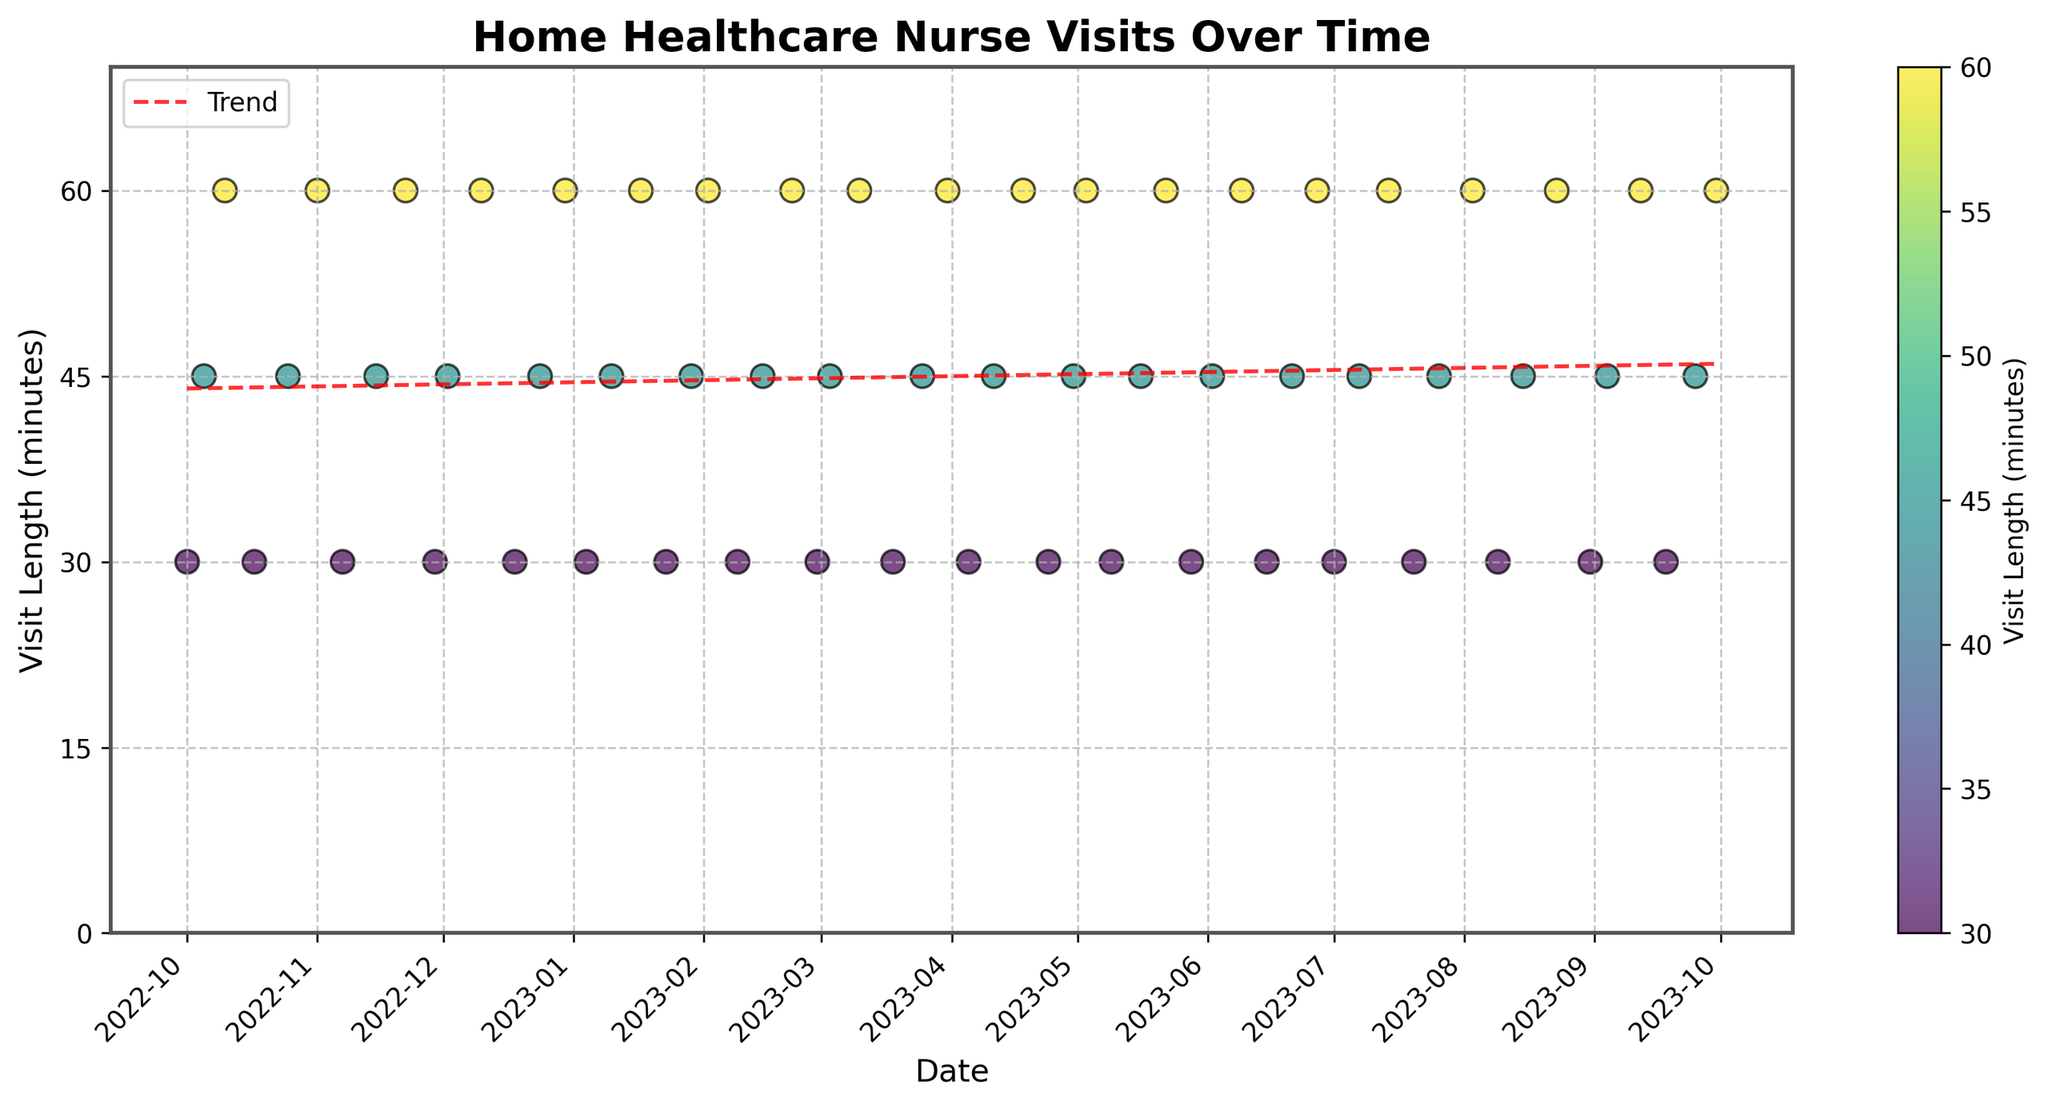What's the title of the figure? The title of the figure is displayed at the top of the chart in bold font. It typically describes the data shown in the plot.
Answer: Home Healthcare Nurse Visits Over Time How many months are covered in the plot? Each x-axis tick represents a month, starting from 2022-10 to 2023-09. To count the months in between, we include both the start and end months.
Answer: 12 What is the maximum visit duration recorded in the plot? The y-axis shows the visit durations in minutes, and the data points and colorbar reflect these values. The highest y-value visible will indicate the maximum duration.
Answer: 60 minutes Which month had the fewest visits? By observing the density of points per month along the x-axis, we can identify which month has the least number of points. This month is likely to have had the fewest visits.
Answer: July What is the average visit length in January 2023? In January 2023, there are five data points: 30, 45, 60, 30, and 45 minutes. Summing these gives 210 minutes, and dividing by the number of visits, 5, gives an average.
Answer: 42 minutes How does the visit trend change over time? The red trend line on the plot illustrates how the visit durations are changing over time. Observing its slope will indicate whether it's increasing, decreasing, or stable.
Answer: Increasing Which month observed the longest single visit compared to other months? By comparing the highest points in each month's vertical spread, the month with the highest data point represents the longest single visit.
Answer: November How does the visit length vary within each month? In each month, the spread of data points along the y-axis shows the variance in visit lengths. Months with a wider spread have more variation compared to those with a narrow spread.
Answer: Varies widely What is the total number of visits recorded in the plot? Each data point represents a visit. By counting all data points in the plot, we can find the total number of visits.
Answer: 60 Which month had the most consistent visit lengths? A month with closely clustered data points around a single y-value suggests consistency in visit lengths. Observing the y-values within each month helps identify this.
Answer: October 